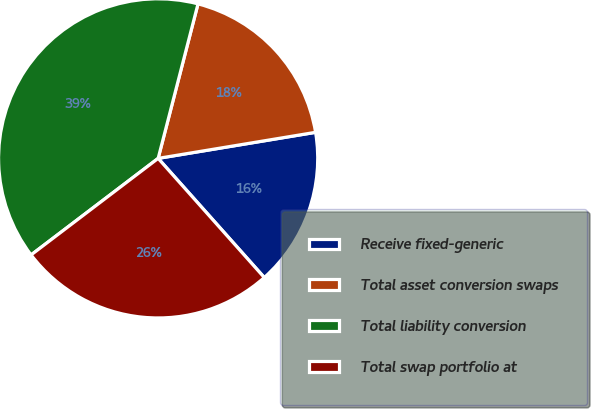Convert chart to OTSL. <chart><loc_0><loc_0><loc_500><loc_500><pie_chart><fcel>Receive fixed-generic<fcel>Total asset conversion swaps<fcel>Total liability conversion<fcel>Total swap portfolio at<nl><fcel>16.03%<fcel>18.37%<fcel>39.36%<fcel>26.24%<nl></chart> 